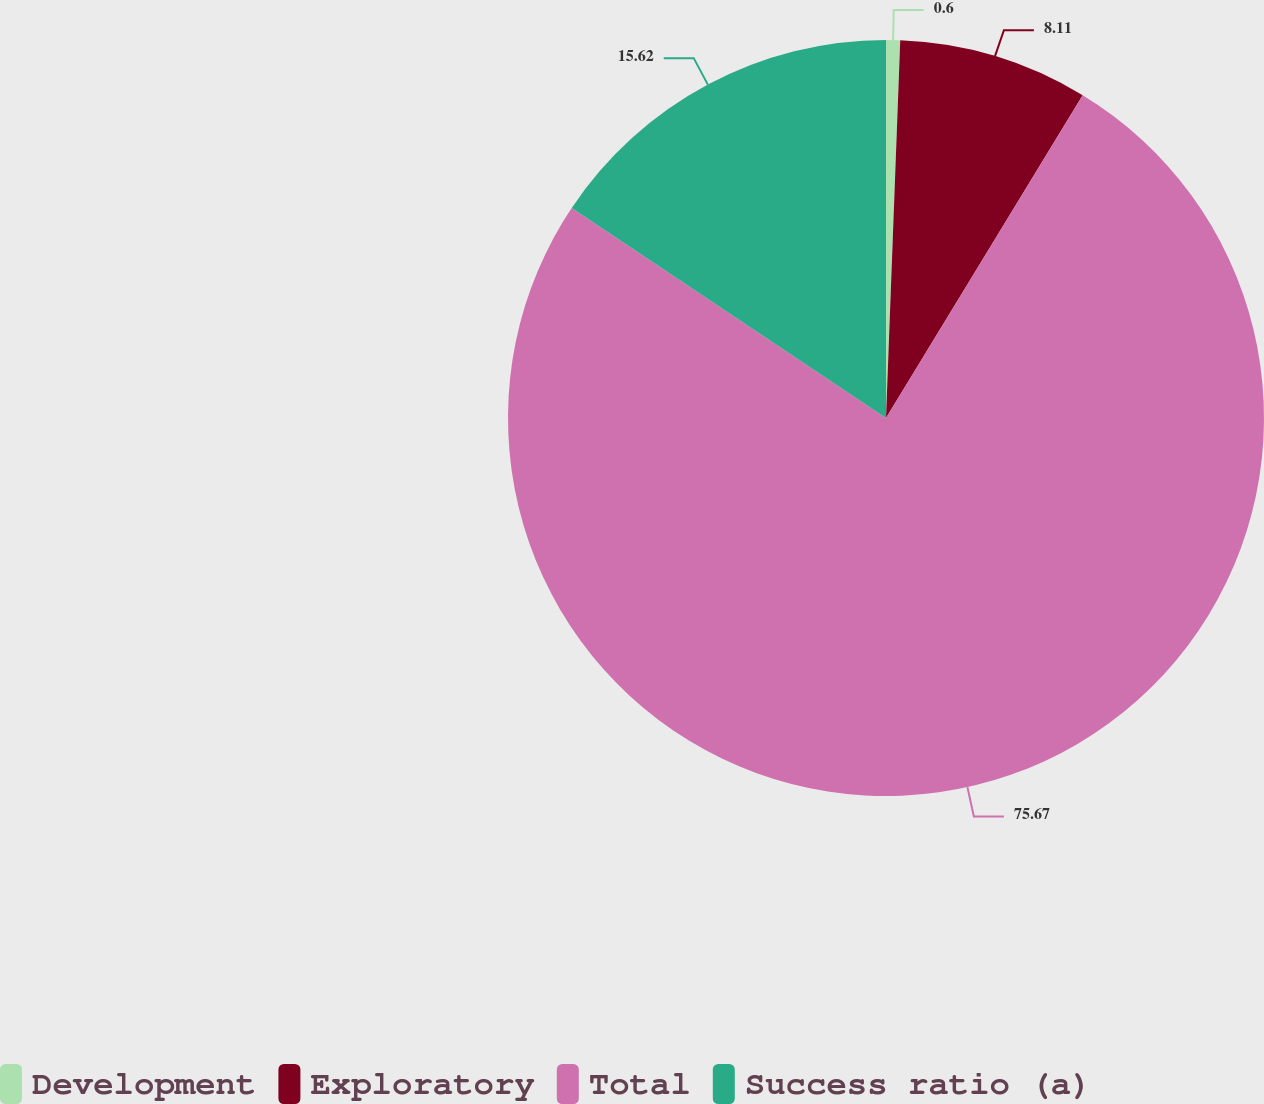<chart> <loc_0><loc_0><loc_500><loc_500><pie_chart><fcel>Development<fcel>Exploratory<fcel>Total<fcel>Success ratio (a)<nl><fcel>0.6%<fcel>8.11%<fcel>75.67%<fcel>15.62%<nl></chart> 